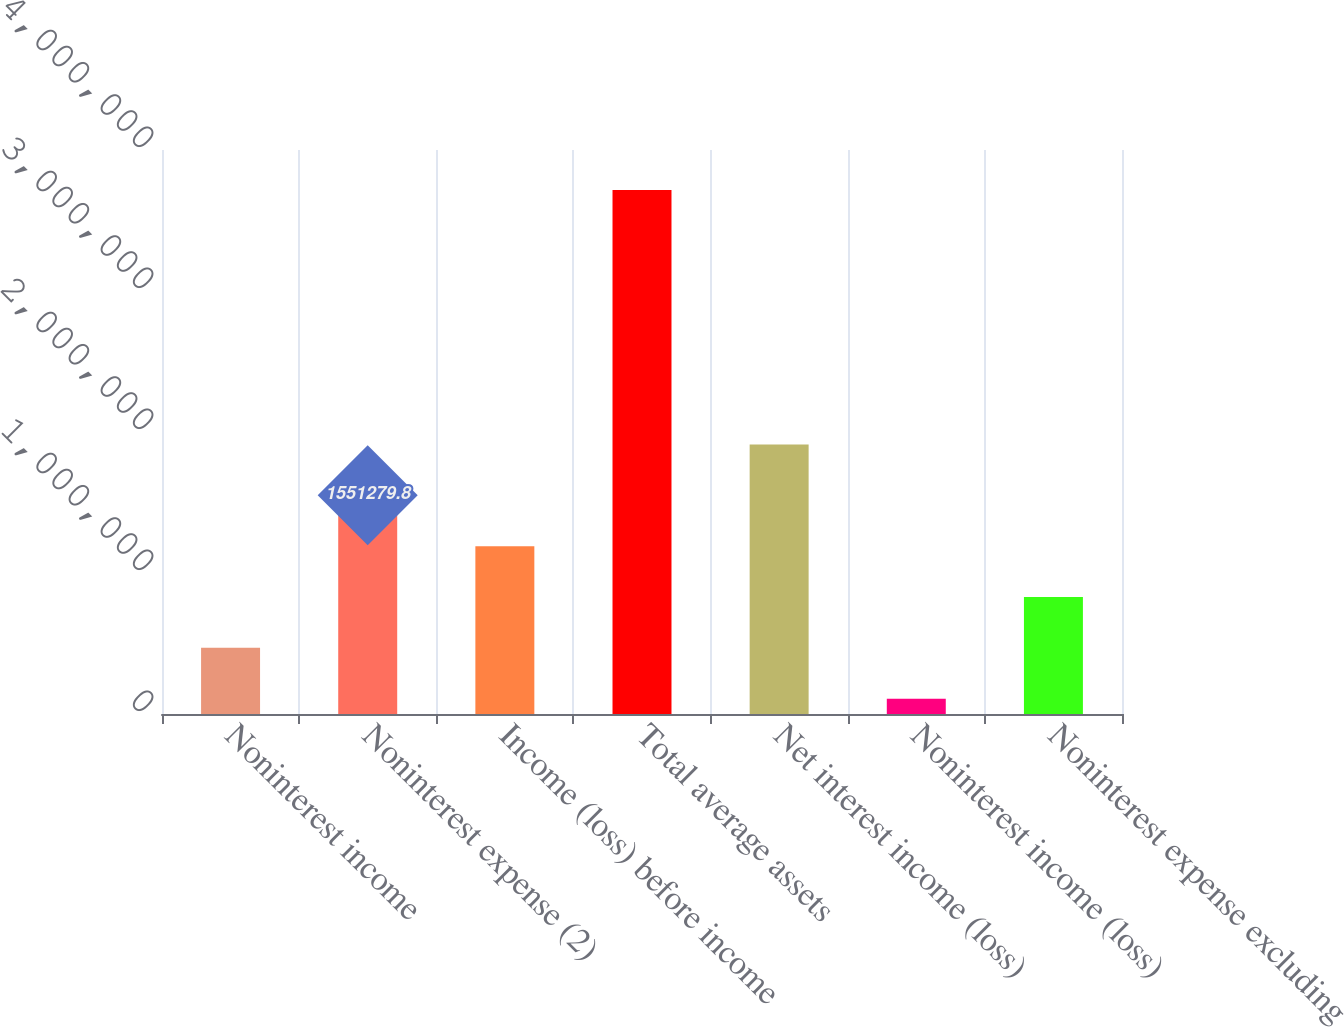Convert chart to OTSL. <chart><loc_0><loc_0><loc_500><loc_500><bar_chart><fcel>Noninterest income<fcel>Noninterest expense (2)<fcel>Income (loss) before income<fcel>Total average assets<fcel>Net interest income (loss)<fcel>Noninterest income (loss)<fcel>Noninterest expense excluding<nl><fcel>469050<fcel>1.55128e+06<fcel>1.19054e+06<fcel>3.71574e+06<fcel>1.91202e+06<fcel>108307<fcel>829793<nl></chart> 